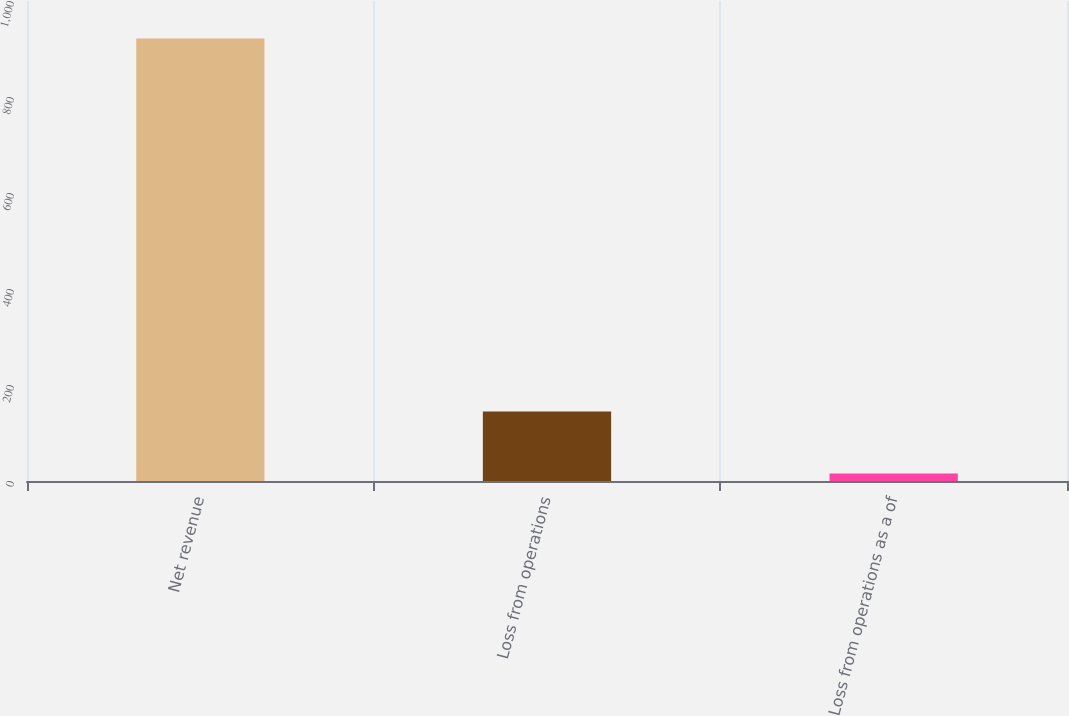<chart> <loc_0><loc_0><loc_500><loc_500><bar_chart><fcel>Net revenue<fcel>Loss from operations<fcel>Loss from operations as a of<nl><fcel>922<fcel>145<fcel>15.7<nl></chart> 